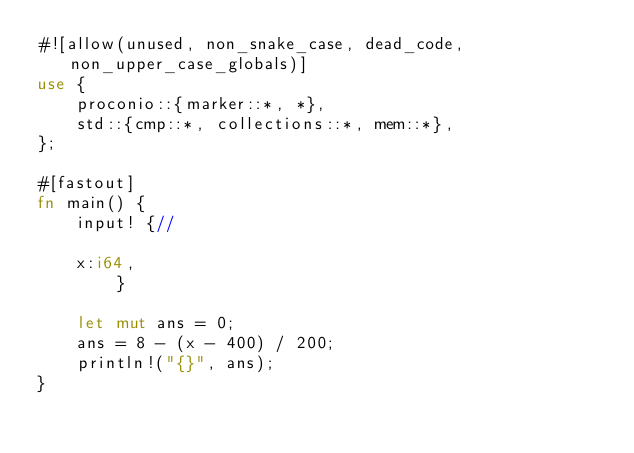<code> <loc_0><loc_0><loc_500><loc_500><_Rust_>#![allow(unused, non_snake_case, dead_code, non_upper_case_globals)]
use {
    proconio::{marker::*, *},
    std::{cmp::*, collections::*, mem::*},
};

#[fastout]
fn main() {
    input! {//

    x:i64,
        }

    let mut ans = 0;
    ans = 8 - (x - 400) / 200;
    println!("{}", ans);
}
</code> 